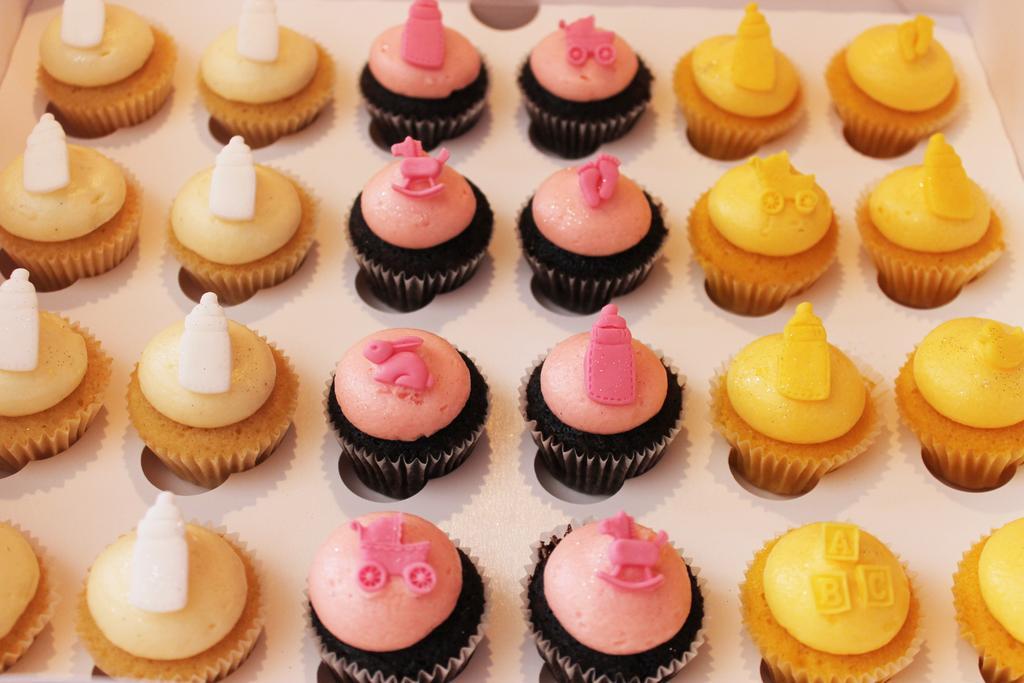Could you give a brief overview of what you see in this image? On the left side, there are brown color cupcakes, on which there are white color creme drops placed. On the right side, there are yellow color cupcakes, on which there are yellow color creme drops. In the middle of this image, there are black color cupcakes, on which there are pink color creme drops. 